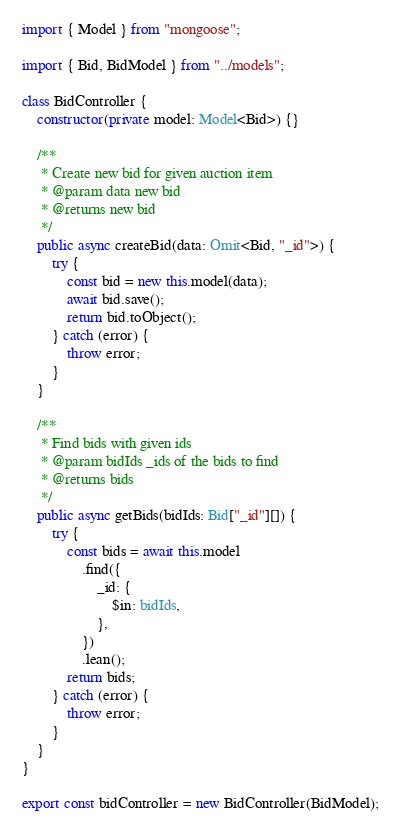<code> <loc_0><loc_0><loc_500><loc_500><_TypeScript_>import { Model } from "mongoose";

import { Bid, BidModel } from "../models";

class BidController {
	constructor(private model: Model<Bid>) {}

	/**
	 * Create new bid for given auction item
	 * @param data new bid
	 * @returns new bid
	 */
	public async createBid(data: Omit<Bid, "_id">) {
		try {
			const bid = new this.model(data);
			await bid.save();
			return bid.toObject();
		} catch (error) {
			throw error;
		}
	}

	/**
	 * Find bids with given ids
	 * @param bidIds _ids of the bids to find
	 * @returns bids
	 */
	public async getBids(bidIds: Bid["_id"][]) {
		try {
			const bids = await this.model
				.find({
					_id: {
						$in: bidIds,
					},
				})
				.lean();
			return bids;
		} catch (error) {
			throw error;
		}
	}
}

export const bidController = new BidController(BidModel);
</code> 